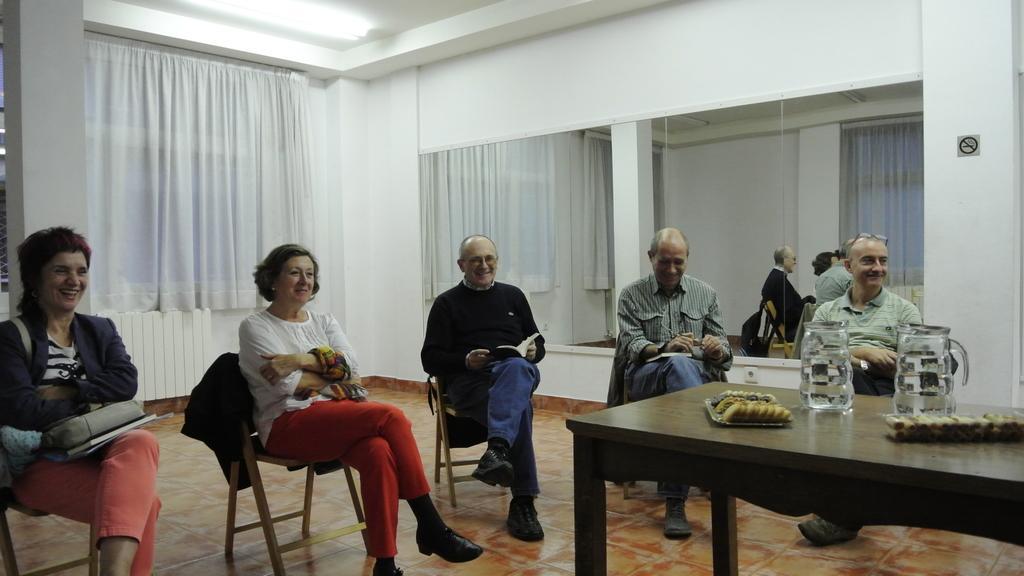Can you describe this image briefly? Five persons are sitting in chairs. Of them three are men and two are women. There is table on which some biscuits and two jugs are placed. 